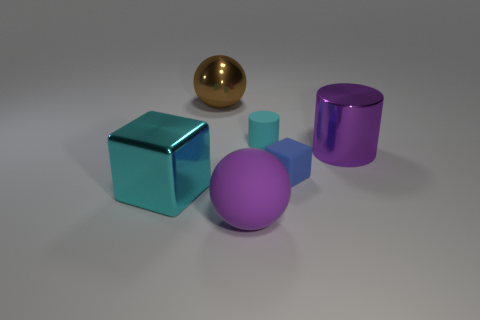What number of other objects are the same color as the small cylinder?
Make the answer very short. 1. How many objects are either green metallic cubes or large shiny objects that are on the left side of the tiny blue matte object?
Your response must be concise. 2. Are there any yellow cylinders made of the same material as the tiny blue thing?
Give a very brief answer. No. There is a cyan thing that is the same size as the metal cylinder; what material is it?
Your response must be concise. Metal. What is the material of the cyan thing right of the ball behind the big purple metal cylinder?
Provide a succinct answer. Rubber. Is the shape of the big object in front of the big cyan thing the same as  the brown metal object?
Provide a succinct answer. Yes. There is a cylinder that is made of the same material as the large cyan block; what is its color?
Ensure brevity in your answer.  Purple. There is a cylinder in front of the small cyan cylinder; what is its material?
Your answer should be very brief. Metal. There is a blue matte thing; is its shape the same as the cyan thing that is right of the shiny sphere?
Offer a terse response. No. What is the thing that is both to the left of the big purple matte sphere and in front of the shiny ball made of?
Ensure brevity in your answer.  Metal. 